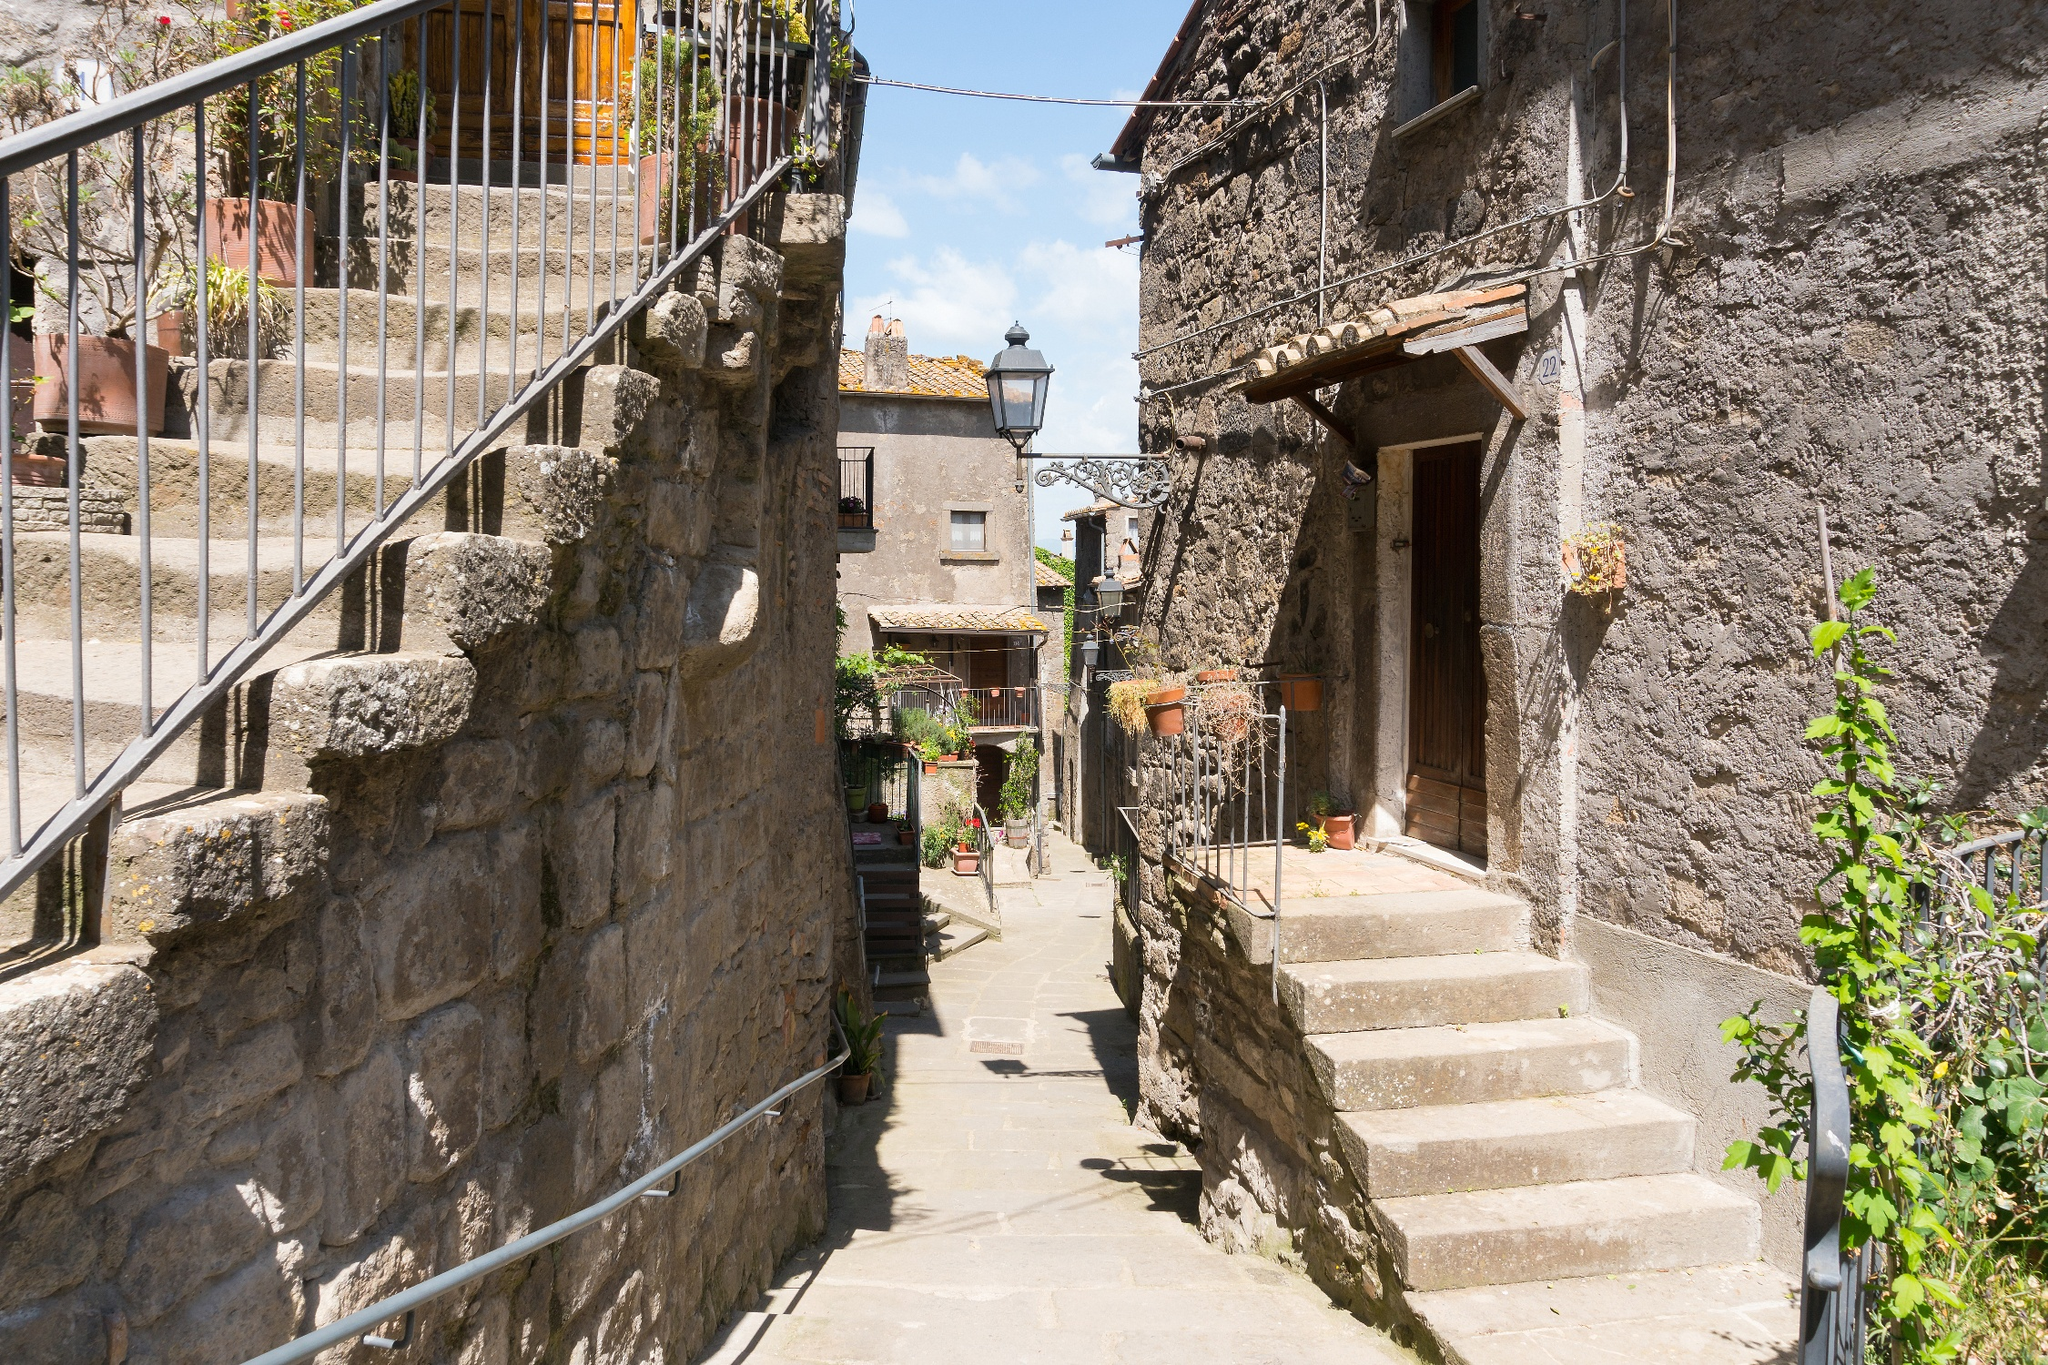Describe the atmosphere of this village street in detail. The atmosphere in this village street is serene and picturesque, epitomizing the tranquility of rural European life. The sunshine bathes the cobblestones, bringing out their rich texture, while shadows cast by the stone walls add depth to the scene. The surrounding buildings, with their rustic stone facades and red tiled roofs, reflect the charm of centuries-old architecture. Lush ivy climbs the walls, interspersed with potted plants, hinting at a community that cherishes nature. The air seems to be filled with the scents of fresh greenery and the subtle aroma of stone warmed by the sun. Absent of people, yet imbued with the quiet hum of daily life, this alleyway feels like a timeless snapshot of peaceful village living. 